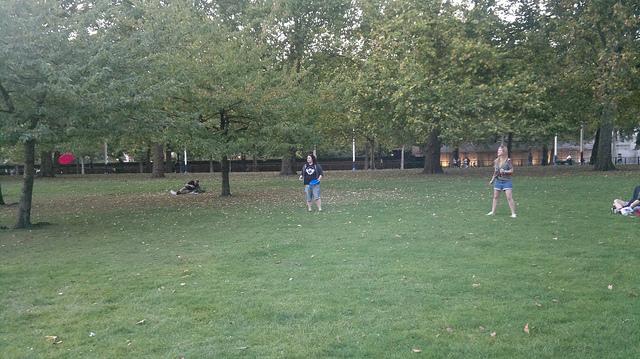How many people are standing?
Short answer required. 2. What has just been thrown in this photograph?
Write a very short answer. Frisbee. Is it a sunny day?
Concise answer only. Yes. How many people can be seen?
Be succinct. 4. 